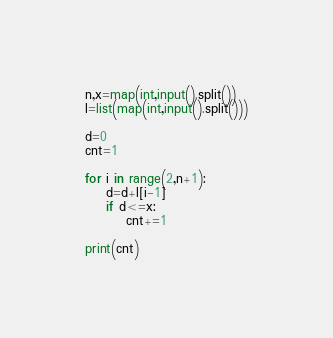<code> <loc_0><loc_0><loc_500><loc_500><_Python_>n,x=map(int,input().split())
l=list(map(int,input().split()))

d=0
cnt=1

for i in range(2,n+1):
    d=d+l[i-1]
    if d<=x:
        cnt+=1

print(cnt)
</code> 